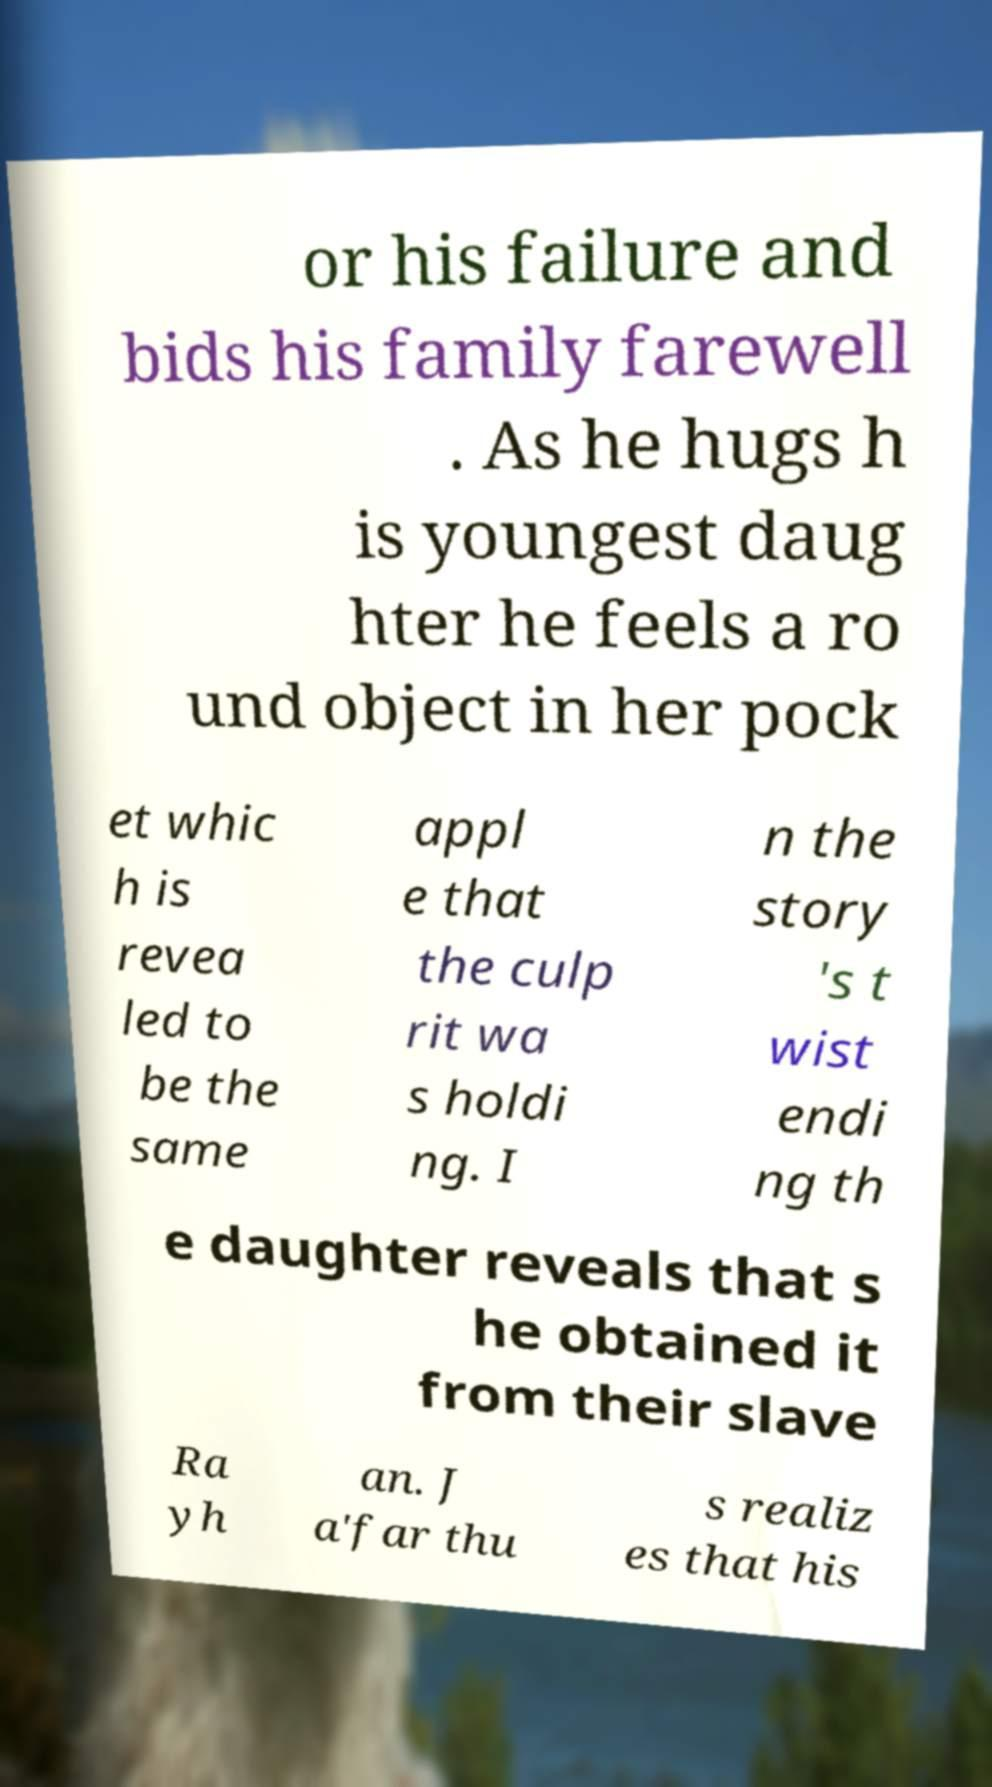Can you read and provide the text displayed in the image?This photo seems to have some interesting text. Can you extract and type it out for me? or his failure and bids his family farewell . As he hugs h is youngest daug hter he feels a ro und object in her pock et whic h is revea led to be the same appl e that the culp rit wa s holdi ng. I n the story 's t wist endi ng th e daughter reveals that s he obtained it from their slave Ra yh an. J a'far thu s realiz es that his 